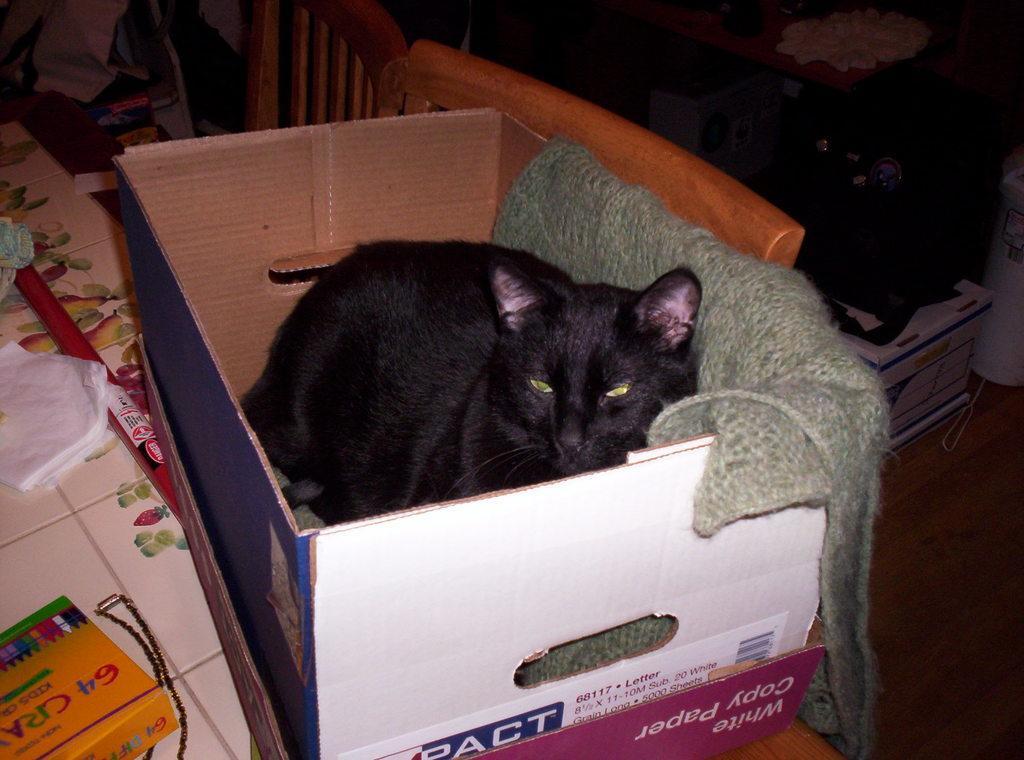In one or two sentences, can you explain what this image depicts? In this image we can see a cat and a cloth inside a cardboard box placed on the surface. On the left side of the image we can see some tissue papers, a rod, box and some objects placed on the table. On the right side of the image we can see a bag on a box, container and some objects on the ground. In the center of the image we can see the chairs. 